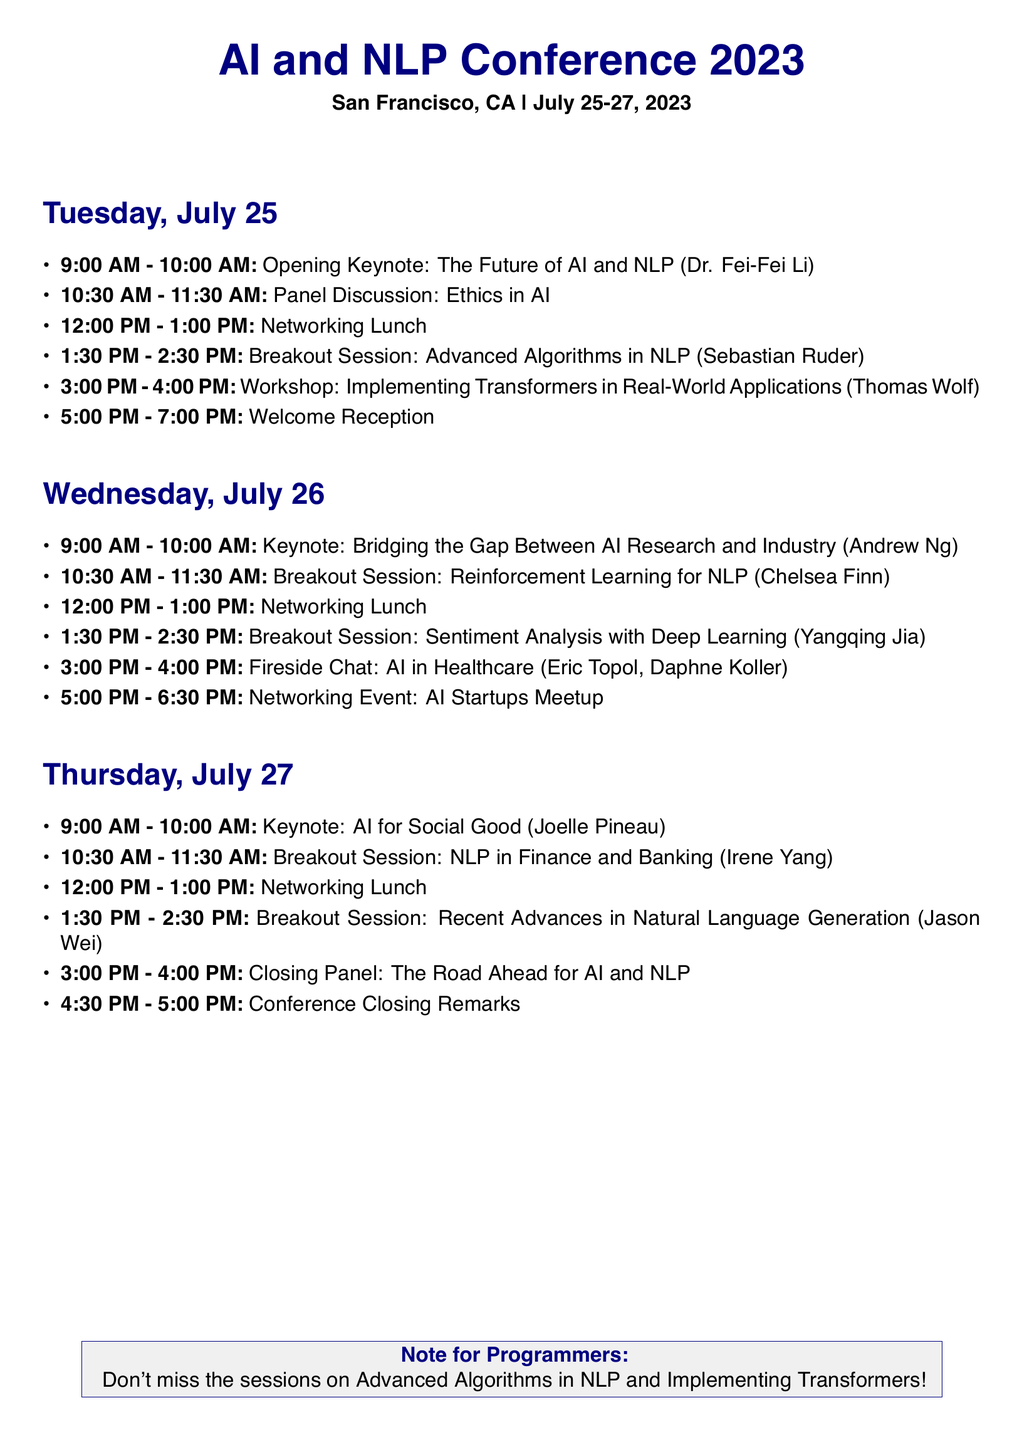what is the date of the conference? The conference is scheduled for July 25-27, 2023.
Answer: July 25-27, 2023 who is delivering the opening keynote speech? The opening keynote is given by Dr. Fei-Fei Li.
Answer: Dr. Fei-Fei Li what time does the panel discussion on ethics in AI start? The panel discussion starts at 10:30 AM on July 25.
Answer: 10:30 AM how long is the networking lunch on Wednesday? The networking lunch is scheduled for one hour from 12:00 PM to 1:00 PM.
Answer: 1 hour which session focuses on AI in healthcare? The session titled "AI in Healthcare" is a fireside chat.
Answer: Fireside Chat who is the speaker for the session on recent advances in natural language generation? The speaker for that session is Jason Wei.
Answer: Jason Wei what keynote speech is scheduled for Thursday at 9:00 AM? The keynote speech at that time is "AI for Social Good".
Answer: AI for Social Good how many breakout sessions are there on July 26? There are three breakout sessions scheduled for that day.
Answer: three what is the focus topic of the closing panel? The closing panel discusses "The Road Ahead for AI and NLP".
Answer: The Road Ahead for AI and NLP 